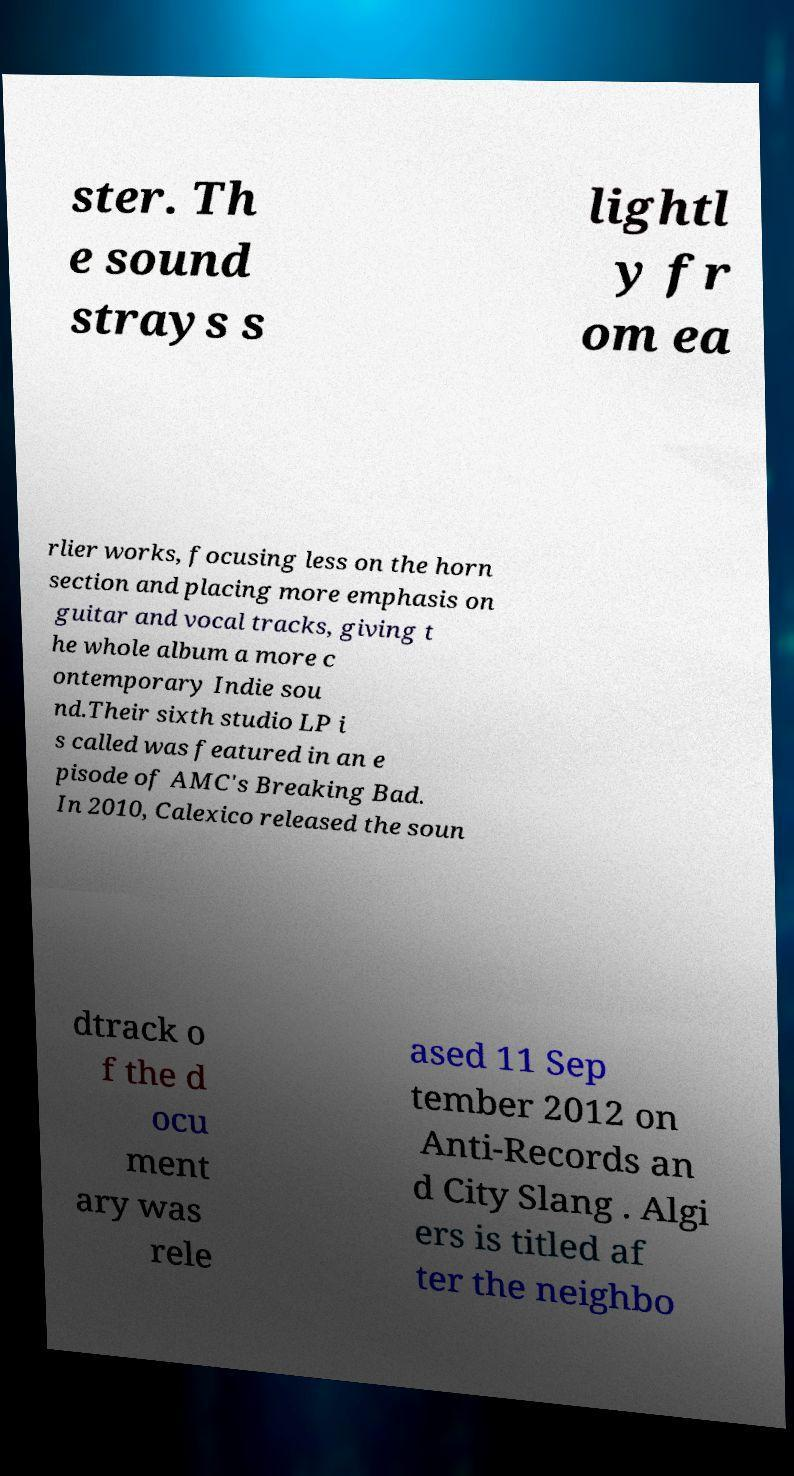Can you accurately transcribe the text from the provided image for me? ster. Th e sound strays s lightl y fr om ea rlier works, focusing less on the horn section and placing more emphasis on guitar and vocal tracks, giving t he whole album a more c ontemporary Indie sou nd.Their sixth studio LP i s called was featured in an e pisode of AMC's Breaking Bad. In 2010, Calexico released the soun dtrack o f the d ocu ment ary was rele ased 11 Sep tember 2012 on Anti-Records an d City Slang . Algi ers is titled af ter the neighbo 